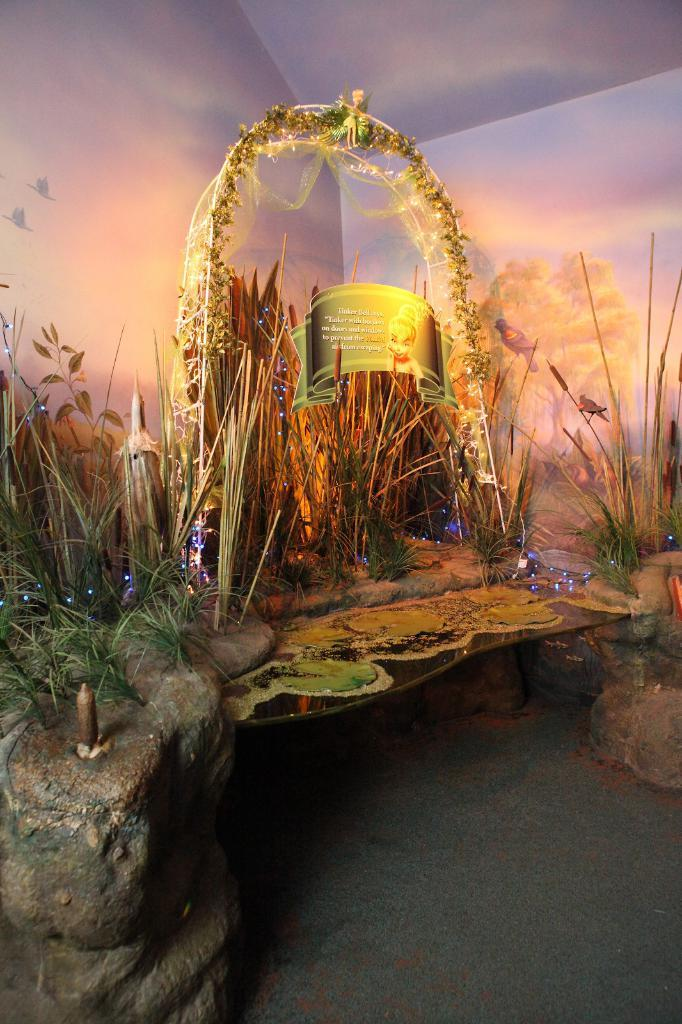What is the primary element present in the image? There is water in the image. What can be seen on the wall in the image? There is a white color wall in the image. What type of vegetation is present in the image? There are plants in the image. What additional feature is present in the image? There is a banner in the image. What type of illumination is present in the image? There are lights in the image. What type of powder is being used to create the turkey shape in the image? There is no turkey or powder present in the image. Can you tell me how many chess pieces are visible in the image? There are no chess pieces present in the image. 